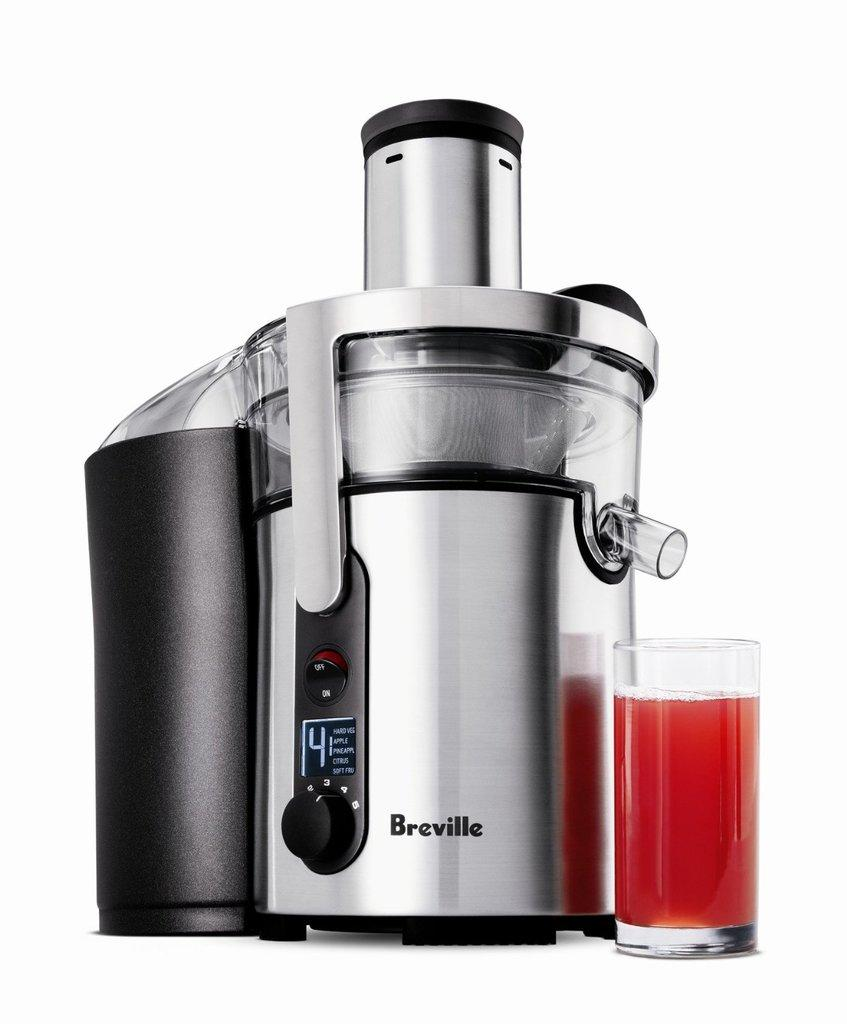<image>
Summarize the visual content of the image. Breville type machine that is preparing a red drink on setting 4 with Apple and Pineapple. 